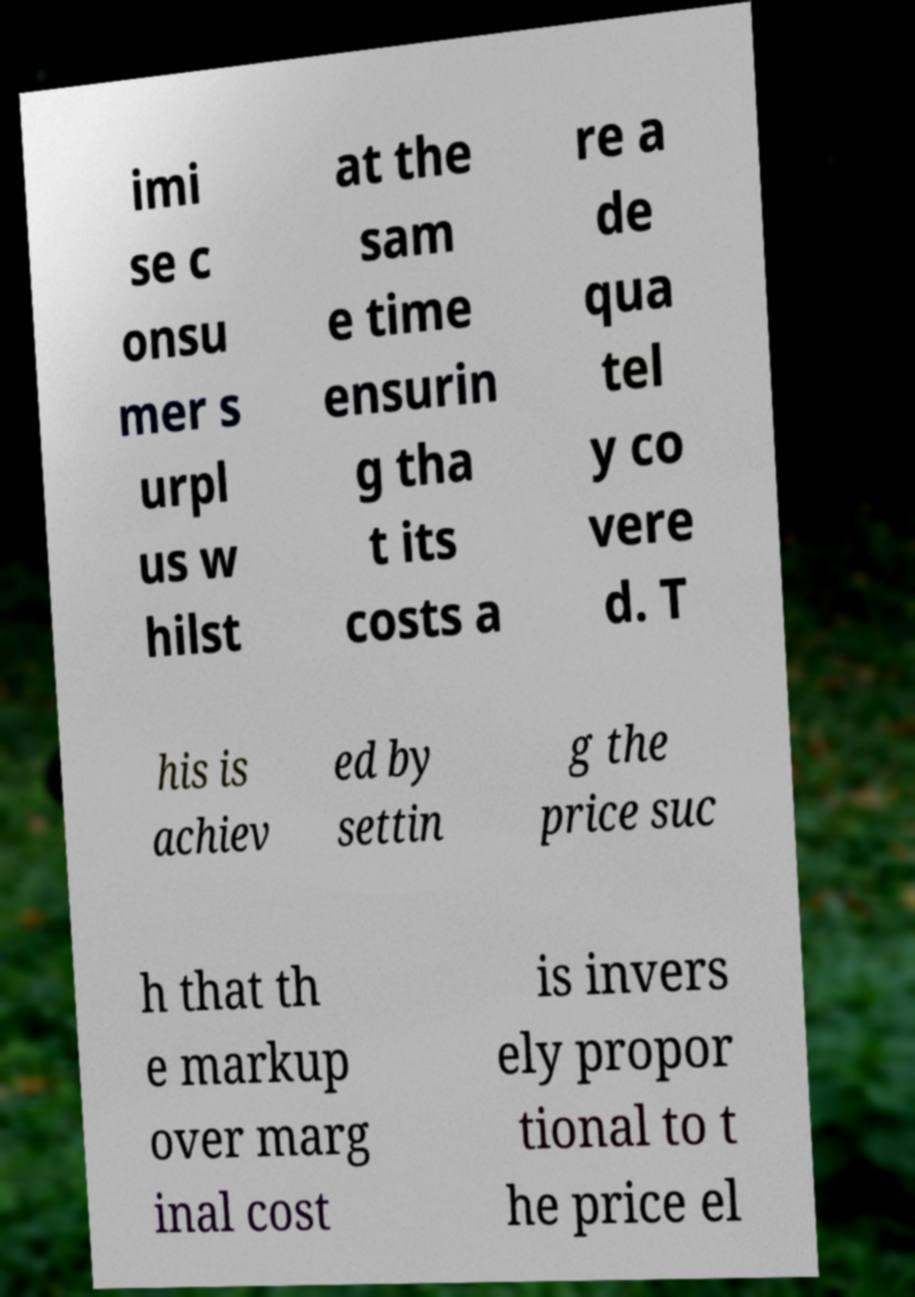There's text embedded in this image that I need extracted. Can you transcribe it verbatim? imi se c onsu mer s urpl us w hilst at the sam e time ensurin g tha t its costs a re a de qua tel y co vere d. T his is achiev ed by settin g the price suc h that th e markup over marg inal cost is invers ely propor tional to t he price el 